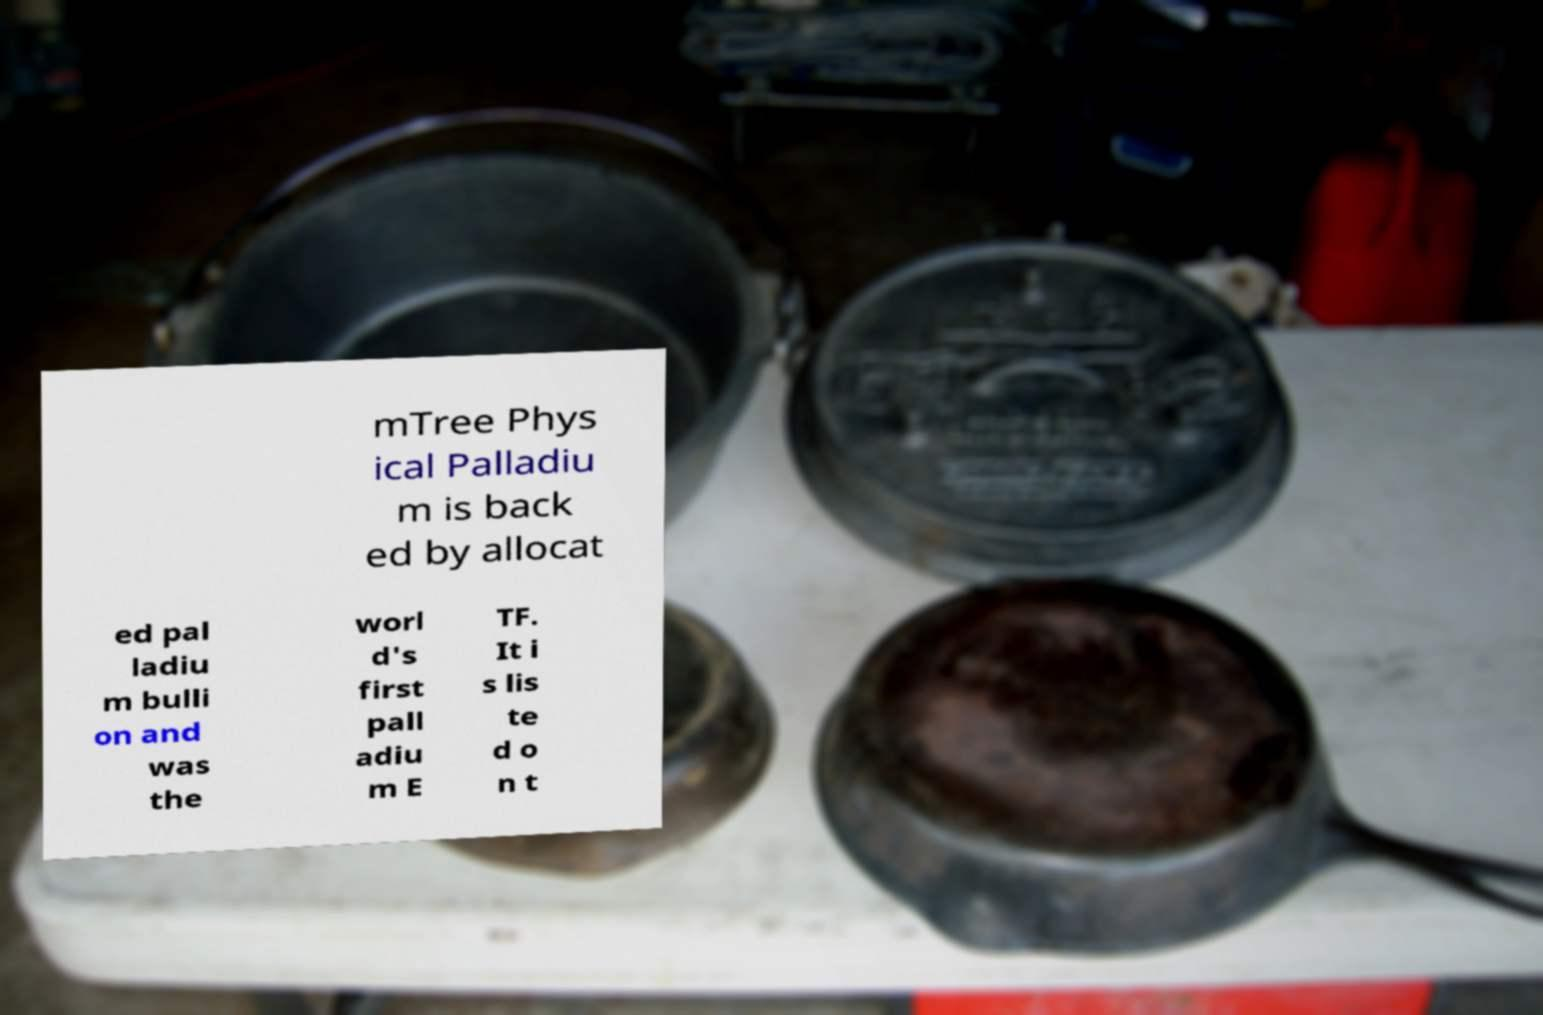Can you read and provide the text displayed in the image?This photo seems to have some interesting text. Can you extract and type it out for me? mTree Phys ical Palladiu m is back ed by allocat ed pal ladiu m bulli on and was the worl d's first pall adiu m E TF. It i s lis te d o n t 